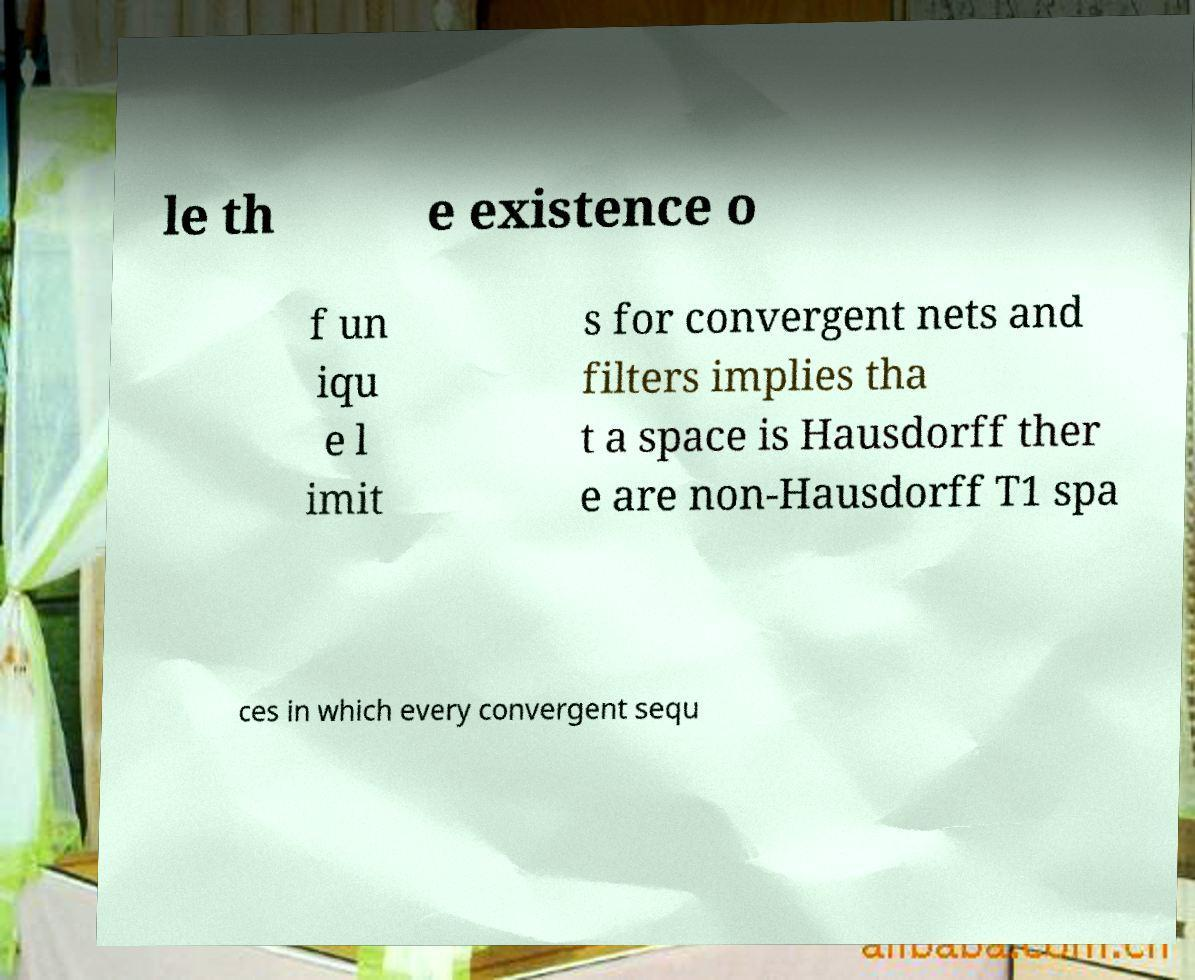Please read and relay the text visible in this image. What does it say? le th e existence o f un iqu e l imit s for convergent nets and filters implies tha t a space is Hausdorff ther e are non-Hausdorff T1 spa ces in which every convergent sequ 